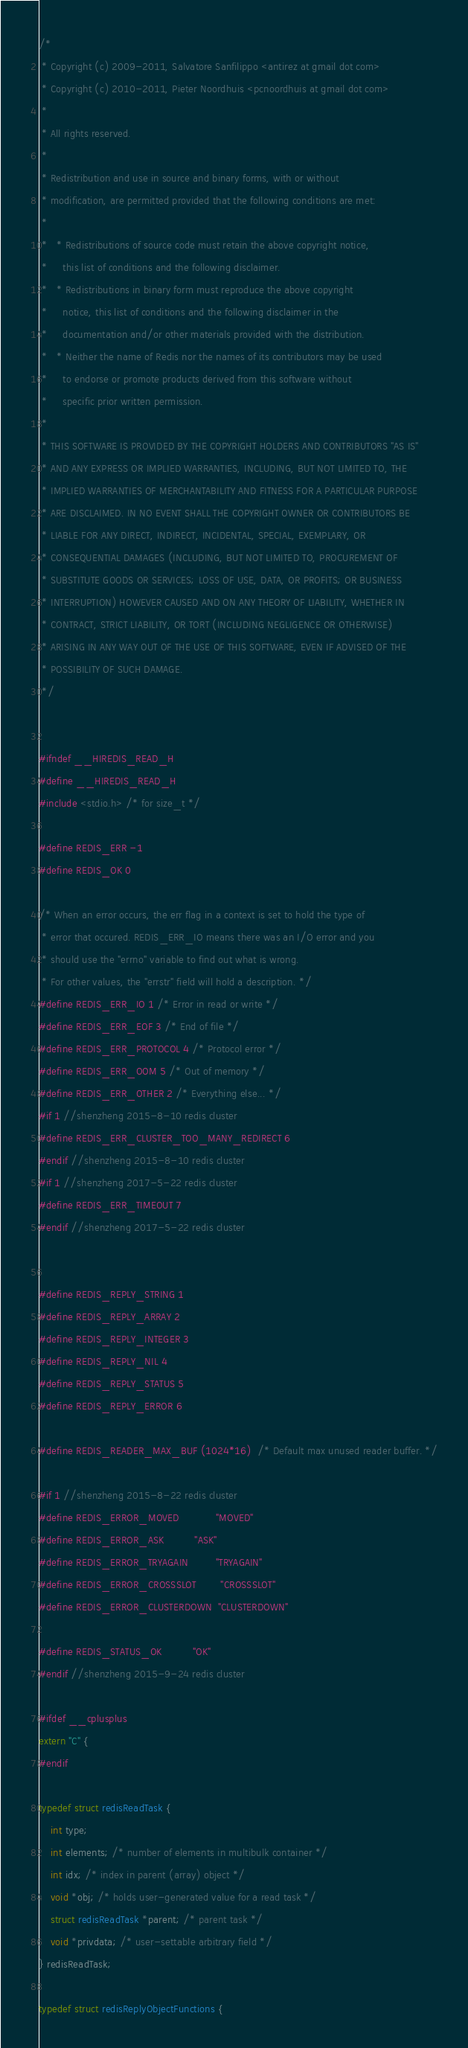<code> <loc_0><loc_0><loc_500><loc_500><_C_>/*
 * Copyright (c) 2009-2011, Salvatore Sanfilippo <antirez at gmail dot com>
 * Copyright (c) 2010-2011, Pieter Noordhuis <pcnoordhuis at gmail dot com>
 *
 * All rights reserved.
 *
 * Redistribution and use in source and binary forms, with or without
 * modification, are permitted provided that the following conditions are met:
 *
 *   * Redistributions of source code must retain the above copyright notice,
 *     this list of conditions and the following disclaimer.
 *   * Redistributions in binary form must reproduce the above copyright
 *     notice, this list of conditions and the following disclaimer in the
 *     documentation and/or other materials provided with the distribution.
 *   * Neither the name of Redis nor the names of its contributors may be used
 *     to endorse or promote products derived from this software without
 *     specific prior written permission.
 *
 * THIS SOFTWARE IS PROVIDED BY THE COPYRIGHT HOLDERS AND CONTRIBUTORS "AS IS"
 * AND ANY EXPRESS OR IMPLIED WARRANTIES, INCLUDING, BUT NOT LIMITED TO, THE
 * IMPLIED WARRANTIES OF MERCHANTABILITY AND FITNESS FOR A PARTICULAR PURPOSE
 * ARE DISCLAIMED. IN NO EVENT SHALL THE COPYRIGHT OWNER OR CONTRIBUTORS BE
 * LIABLE FOR ANY DIRECT, INDIRECT, INCIDENTAL, SPECIAL, EXEMPLARY, OR
 * CONSEQUENTIAL DAMAGES (INCLUDING, BUT NOT LIMITED TO, PROCUREMENT OF
 * SUBSTITUTE GOODS OR SERVICES; LOSS OF USE, DATA, OR PROFITS; OR BUSINESS
 * INTERRUPTION) HOWEVER CAUSED AND ON ANY THEORY OF LIABILITY, WHETHER IN
 * CONTRACT, STRICT LIABILITY, OR TORT (INCLUDING NEGLIGENCE OR OTHERWISE)
 * ARISING IN ANY WAY OUT OF THE USE OF THIS SOFTWARE, EVEN IF ADVISED OF THE
 * POSSIBILITY OF SUCH DAMAGE.
 */


#ifndef __HIREDIS_READ_H
#define __HIREDIS_READ_H
#include <stdio.h> /* for size_t */

#define REDIS_ERR -1
#define REDIS_OK 0

/* When an error occurs, the err flag in a context is set to hold the type of
 * error that occured. REDIS_ERR_IO means there was an I/O error and you
 * should use the "errno" variable to find out what is wrong.
 * For other values, the "errstr" field will hold a description. */
#define REDIS_ERR_IO 1 /* Error in read or write */
#define REDIS_ERR_EOF 3 /* End of file */
#define REDIS_ERR_PROTOCOL 4 /* Protocol error */
#define REDIS_ERR_OOM 5 /* Out of memory */
#define REDIS_ERR_OTHER 2 /* Everything else... */
#if 1 //shenzheng 2015-8-10 redis cluster
#define REDIS_ERR_CLUSTER_TOO_MANY_REDIRECT 6
#endif //shenzheng 2015-8-10 redis cluster
#if 1 //shenzheng 2017-5-22 redis cluster
#define REDIS_ERR_TIMEOUT 7
#endif //shenzheng 2017-5-22 redis cluster


#define REDIS_REPLY_STRING 1
#define REDIS_REPLY_ARRAY 2
#define REDIS_REPLY_INTEGER 3
#define REDIS_REPLY_NIL 4
#define REDIS_REPLY_STATUS 5
#define REDIS_REPLY_ERROR 6

#define REDIS_READER_MAX_BUF (1024*16)  /* Default max unused reader buffer. */

#if 1 //shenzheng 2015-8-22 redis cluster
#define REDIS_ERROR_MOVED 			"MOVED"
#define REDIS_ERROR_ASK 			"ASK"
#define REDIS_ERROR_TRYAGAIN 		"TRYAGAIN"
#define REDIS_ERROR_CROSSSLOT 		"CROSSSLOT"
#define REDIS_ERROR_CLUSTERDOWN 	"CLUSTERDOWN"

#define REDIS_STATUS_OK 			"OK"
#endif //shenzheng 2015-9-24 redis cluster

#ifdef __cplusplus
extern "C" {
#endif

typedef struct redisReadTask {
    int type;
    int elements; /* number of elements in multibulk container */
    int idx; /* index in parent (array) object */
    void *obj; /* holds user-generated value for a read task */
    struct redisReadTask *parent; /* parent task */
    void *privdata; /* user-settable arbitrary field */
} redisReadTask;

typedef struct redisReplyObjectFunctions {</code> 